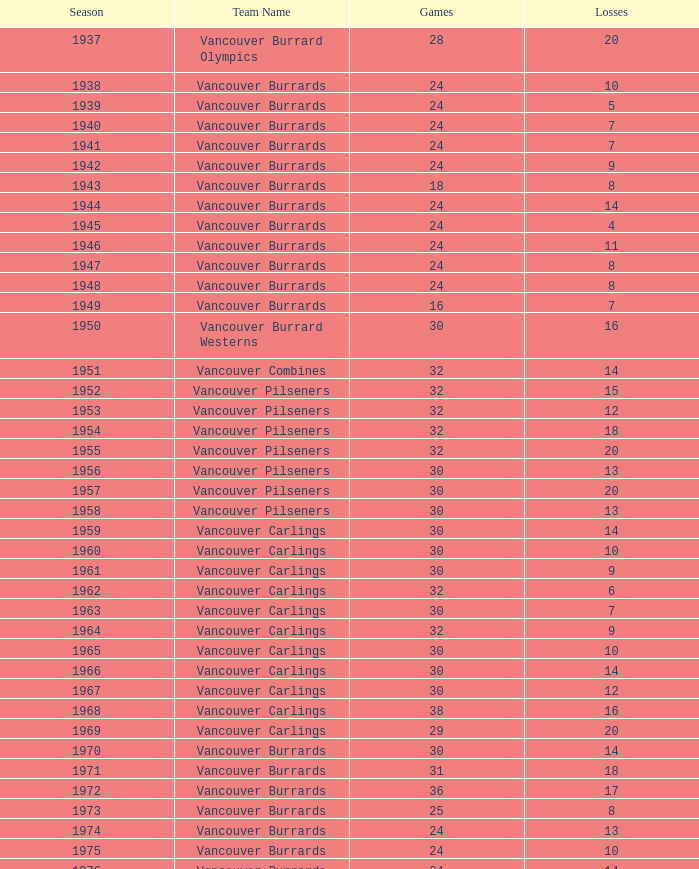How many points have the vancouver carlings accumulated with under 12 losses and more than 32 games played? 0.0. Can you parse all the data within this table? {'header': ['Season', 'Team Name', 'Games', 'Losses'], 'rows': [['1937', 'Vancouver Burrard Olympics', '28', '20'], ['1938', 'Vancouver Burrards', '24', '10'], ['1939', 'Vancouver Burrards', '24', '5'], ['1940', 'Vancouver Burrards', '24', '7'], ['1941', 'Vancouver Burrards', '24', '7'], ['1942', 'Vancouver Burrards', '24', '9'], ['1943', 'Vancouver Burrards', '18', '8'], ['1944', 'Vancouver Burrards', '24', '14'], ['1945', 'Vancouver Burrards', '24', '4'], ['1946', 'Vancouver Burrards', '24', '11'], ['1947', 'Vancouver Burrards', '24', '8'], ['1948', 'Vancouver Burrards', '24', '8'], ['1949', 'Vancouver Burrards', '16', '7'], ['1950', 'Vancouver Burrard Westerns', '30', '16'], ['1951', 'Vancouver Combines', '32', '14'], ['1952', 'Vancouver Pilseners', '32', '15'], ['1953', 'Vancouver Pilseners', '32', '12'], ['1954', 'Vancouver Pilseners', '32', '18'], ['1955', 'Vancouver Pilseners', '32', '20'], ['1956', 'Vancouver Pilseners', '30', '13'], ['1957', 'Vancouver Pilseners', '30', '20'], ['1958', 'Vancouver Pilseners', '30', '13'], ['1959', 'Vancouver Carlings', '30', '14'], ['1960', 'Vancouver Carlings', '30', '10'], ['1961', 'Vancouver Carlings', '30', '9'], ['1962', 'Vancouver Carlings', '32', '6'], ['1963', 'Vancouver Carlings', '30', '7'], ['1964', 'Vancouver Carlings', '32', '9'], ['1965', 'Vancouver Carlings', '30', '10'], ['1966', 'Vancouver Carlings', '30', '14'], ['1967', 'Vancouver Carlings', '30', '12'], ['1968', 'Vancouver Carlings', '38', '16'], ['1969', 'Vancouver Carlings', '29', '20'], ['1970', 'Vancouver Burrards', '30', '14'], ['1971', 'Vancouver Burrards', '31', '18'], ['1972', 'Vancouver Burrards', '36', '17'], ['1973', 'Vancouver Burrards', '25', '8'], ['1974', 'Vancouver Burrards', '24', '13'], ['1975', 'Vancouver Burrards', '24', '10'], ['1976', 'Vancouver Burrards', '24', '14'], ['1977', 'Vancouver Burrards', '24', '7'], ['1978', 'Vancouver Burrards', '24', '13'], ['1979', 'Vancouver Burrards', '30', '19'], ['1980', 'Vancouver Burrards', '24', '13'], ['1981', 'Vancouver Burrards', '24', '12'], ['1982', 'Vancouver Burrards', '24', '12'], ['1983', 'Vancouver Burrards', '24', '10'], ['1984', 'Vancouver Burrards', '24', '15'], ['1985', 'Vancouver Burrards', '24', '13'], ['1986', 'Vancouver Burrards', '24', '11'], ['1987', 'Vancouver Burrards', '24', '14'], ['1988', 'Vancouver Burrards', '24', '13'], ['1989', 'Vancouver Burrards', '24', '15'], ['1990', 'Vancouver Burrards', '24', '8'], ['1991', 'Vancouver Burrards', '24', '16'], ['1992', 'Vancouver Burrards', '24', '15'], ['1993', 'Vancouver Burrards', '24', '20'], ['1994', 'Surrey Burrards', '20', '12'], ['1995', 'Surrey Burrards', '25', '19'], ['1996', 'Maple Ridge Burrards', '20', '8'], ['1997', 'Maple Ridge Burrards', '20', '8'], ['1998', 'Maple Ridge Burrards', '25', '8'], ['1999', 'Maple Ridge Burrards', '25', '15'], ['2000', 'Maple Ridge Burrards', '25', '16'], ['2001', 'Maple Ridge Burrards', '20', '16'], ['2002', 'Maple Ridge Burrards', '20', '15'], ['2003', 'Maple Ridge Burrards', '20', '15'], ['2004', 'Maple Ridge Burrards', '20', '12'], ['2005', 'Maple Ridge Burrards', '18', '8'], ['2006', 'Maple Ridge Burrards', '18', '11'], ['2007', 'Maple Ridge Burrards', '18', '11'], ['2008', 'Maple Ridge Burrards', '18', '13'], ['2009', 'Maple Ridge Burrards', '18', '11'], ['2010', 'Maple Ridge Burrards', '18', '9'], ['Total', '74 seasons', '1,879', '913']]} 